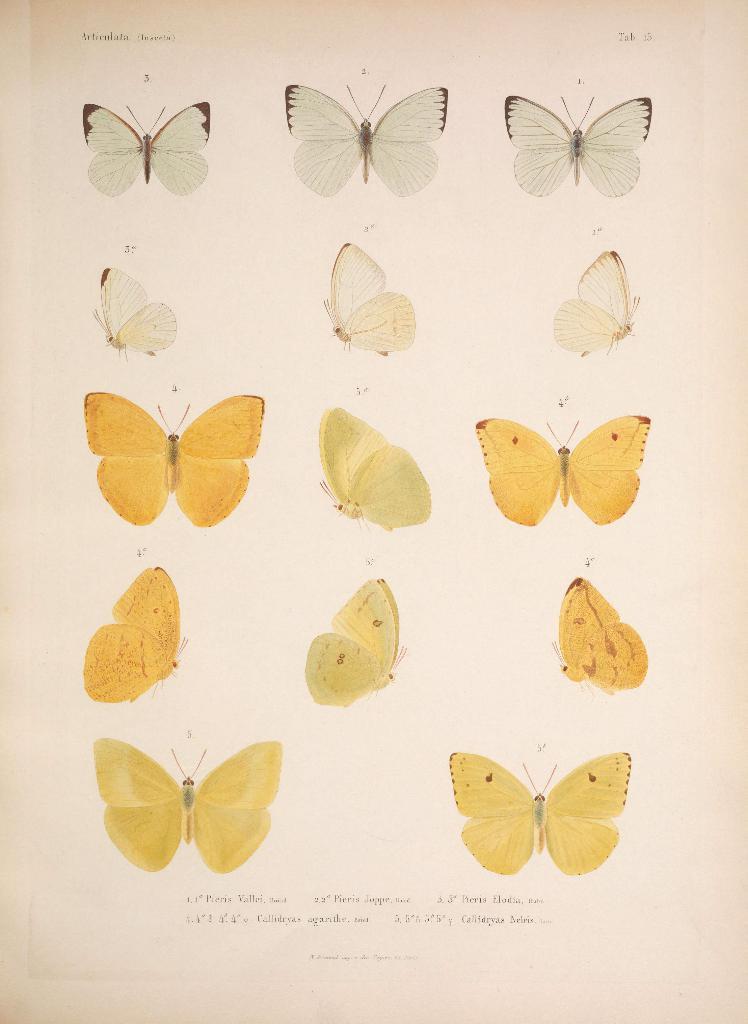Could you give a brief overview of what you see in this image? In this image, I can see the photos of different types of butterflies and there are words on a paper. 